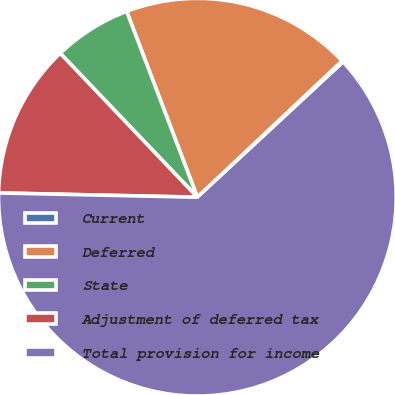Convert chart to OTSL. <chart><loc_0><loc_0><loc_500><loc_500><pie_chart><fcel>Current<fcel>Deferred<fcel>State<fcel>Adjustment of deferred tax<fcel>Total provision for income<nl><fcel>0.12%<fcel>18.76%<fcel>6.33%<fcel>12.54%<fcel>62.25%<nl></chart> 